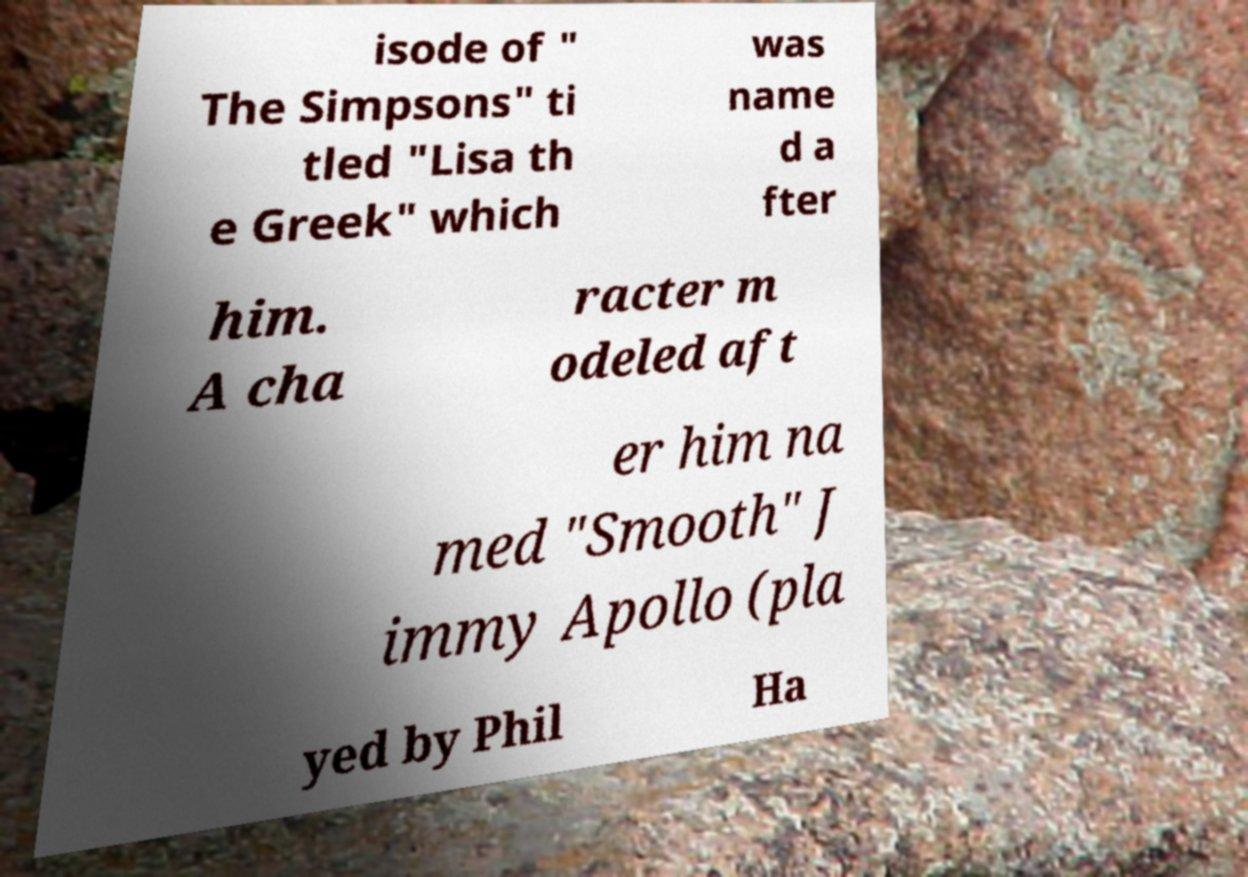Could you assist in decoding the text presented in this image and type it out clearly? isode of " The Simpsons" ti tled "Lisa th e Greek" which was name d a fter him. A cha racter m odeled aft er him na med "Smooth" J immy Apollo (pla yed by Phil Ha 